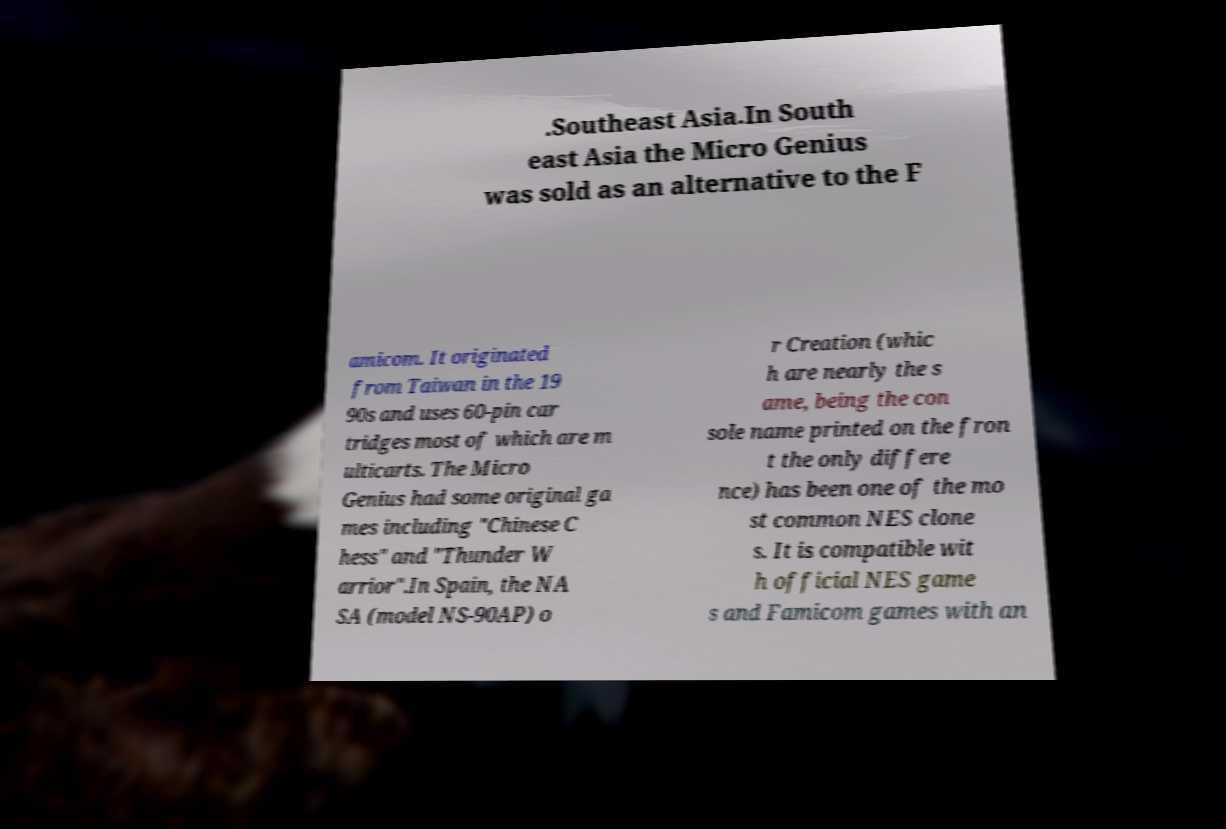Can you read and provide the text displayed in the image?This photo seems to have some interesting text. Can you extract and type it out for me? .Southeast Asia.In South east Asia the Micro Genius was sold as an alternative to the F amicom. It originated from Taiwan in the 19 90s and uses 60-pin car tridges most of which are m ulticarts. The Micro Genius had some original ga mes including "Chinese C hess" and "Thunder W arrior".In Spain, the NA SA (model NS-90AP) o r Creation (whic h are nearly the s ame, being the con sole name printed on the fron t the only differe nce) has been one of the mo st common NES clone s. It is compatible wit h official NES game s and Famicom games with an 